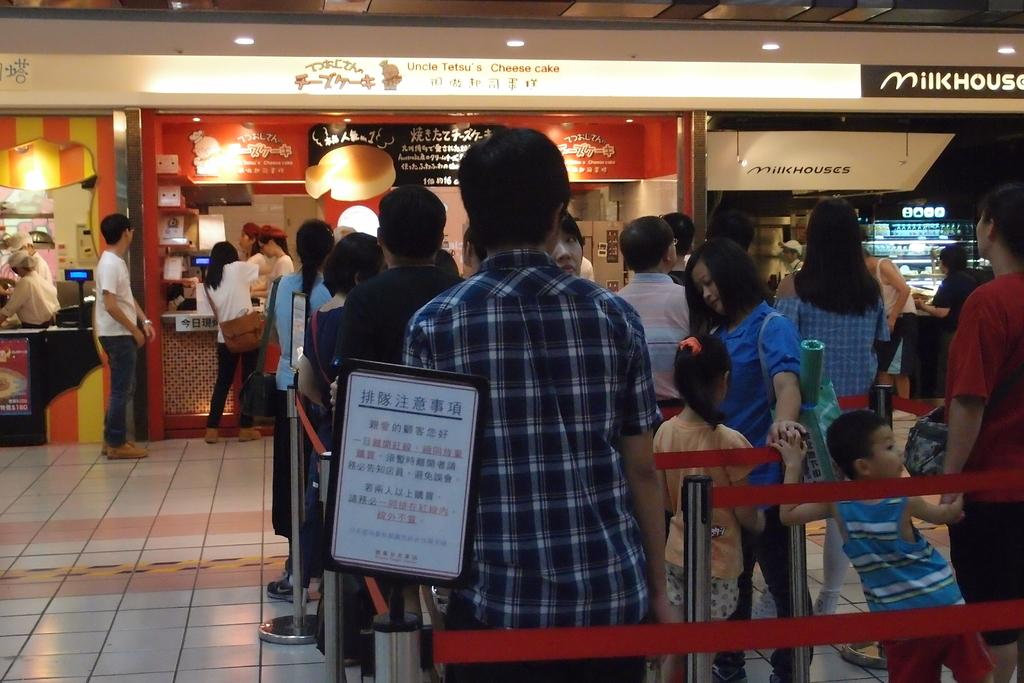How many people are in the image? There are people in the image, but the exact number is not specified. What is the board used for in the image? The purpose of the board in the image is not clear, but it is present. What are the stanchion barriers used for in the image? The stanchion barriers are likely used for crowd control or to guide people in a specific direction. What can be seen on the floor in the image? The floor is visible in the image, but no specific details are provided. What can be seen in the background of the image? In the background of the image, there are ships, lights, and boards. What day of the week is the writer working on their novel in the image? There is no writer or novel mentioned in the image, so it is not possible to determine the day of the week. 